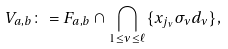<formula> <loc_0><loc_0><loc_500><loc_500>V _ { a , b } \colon = { F } _ { a , b } \cap \bigcap _ { 1 \leq \nu \leq \ell } \{ x _ { j _ { \nu } } \sigma _ { \nu } d _ { \nu } \} ,</formula> 